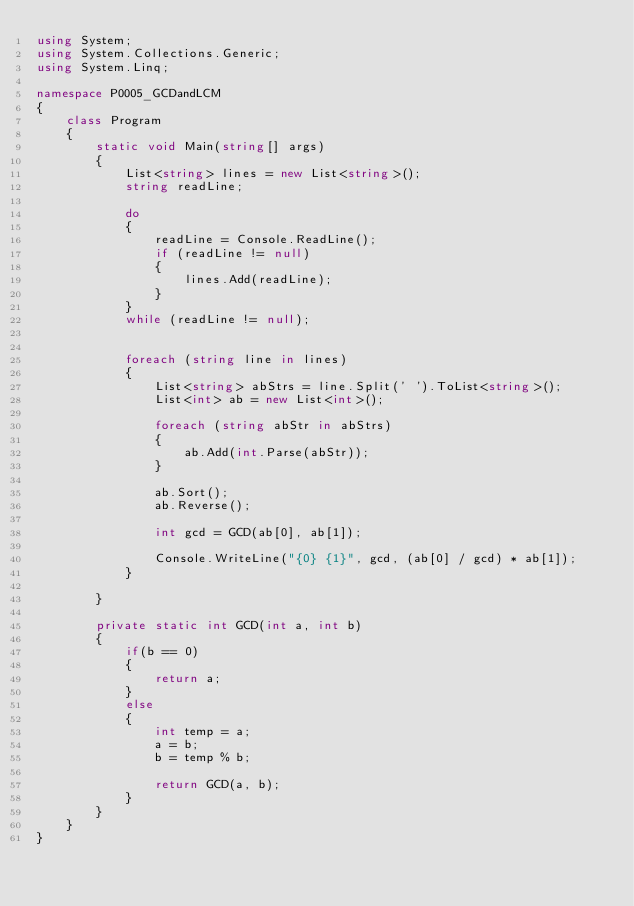Convert code to text. <code><loc_0><loc_0><loc_500><loc_500><_C#_>using System;
using System.Collections.Generic;
using System.Linq;

namespace P0005_GCDandLCM
{
    class Program
    {
        static void Main(string[] args)
        {
            List<string> lines = new List<string>();
            string readLine;

            do
            {
                readLine = Console.ReadLine();
                if (readLine != null)
                {
                    lines.Add(readLine);
                }
            }
            while (readLine != null);


            foreach (string line in lines)
            {
                List<string> abStrs = line.Split(' ').ToList<string>();
                List<int> ab = new List<int>();

                foreach (string abStr in abStrs)
                {
                    ab.Add(int.Parse(abStr));
                }

                ab.Sort();
                ab.Reverse();

                int gcd = GCD(ab[0], ab[1]);

                Console.WriteLine("{0} {1}", gcd, (ab[0] / gcd) * ab[1]);
            }

        }

        private static int GCD(int a, int b) 
        {
            if(b == 0)
            {
                return a;
            }
            else
            {
                int temp = a;
                a = b;
                b = temp % b;

                return GCD(a, b); 
            }
        }
    }
}</code> 